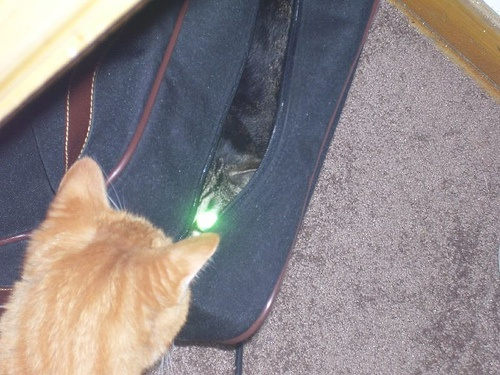Describe the objects in this image and their specific colors. I can see suitcase in lightyellow, gray, black, and darkblue tones and cat in lightyellow, tan, and beige tones in this image. 